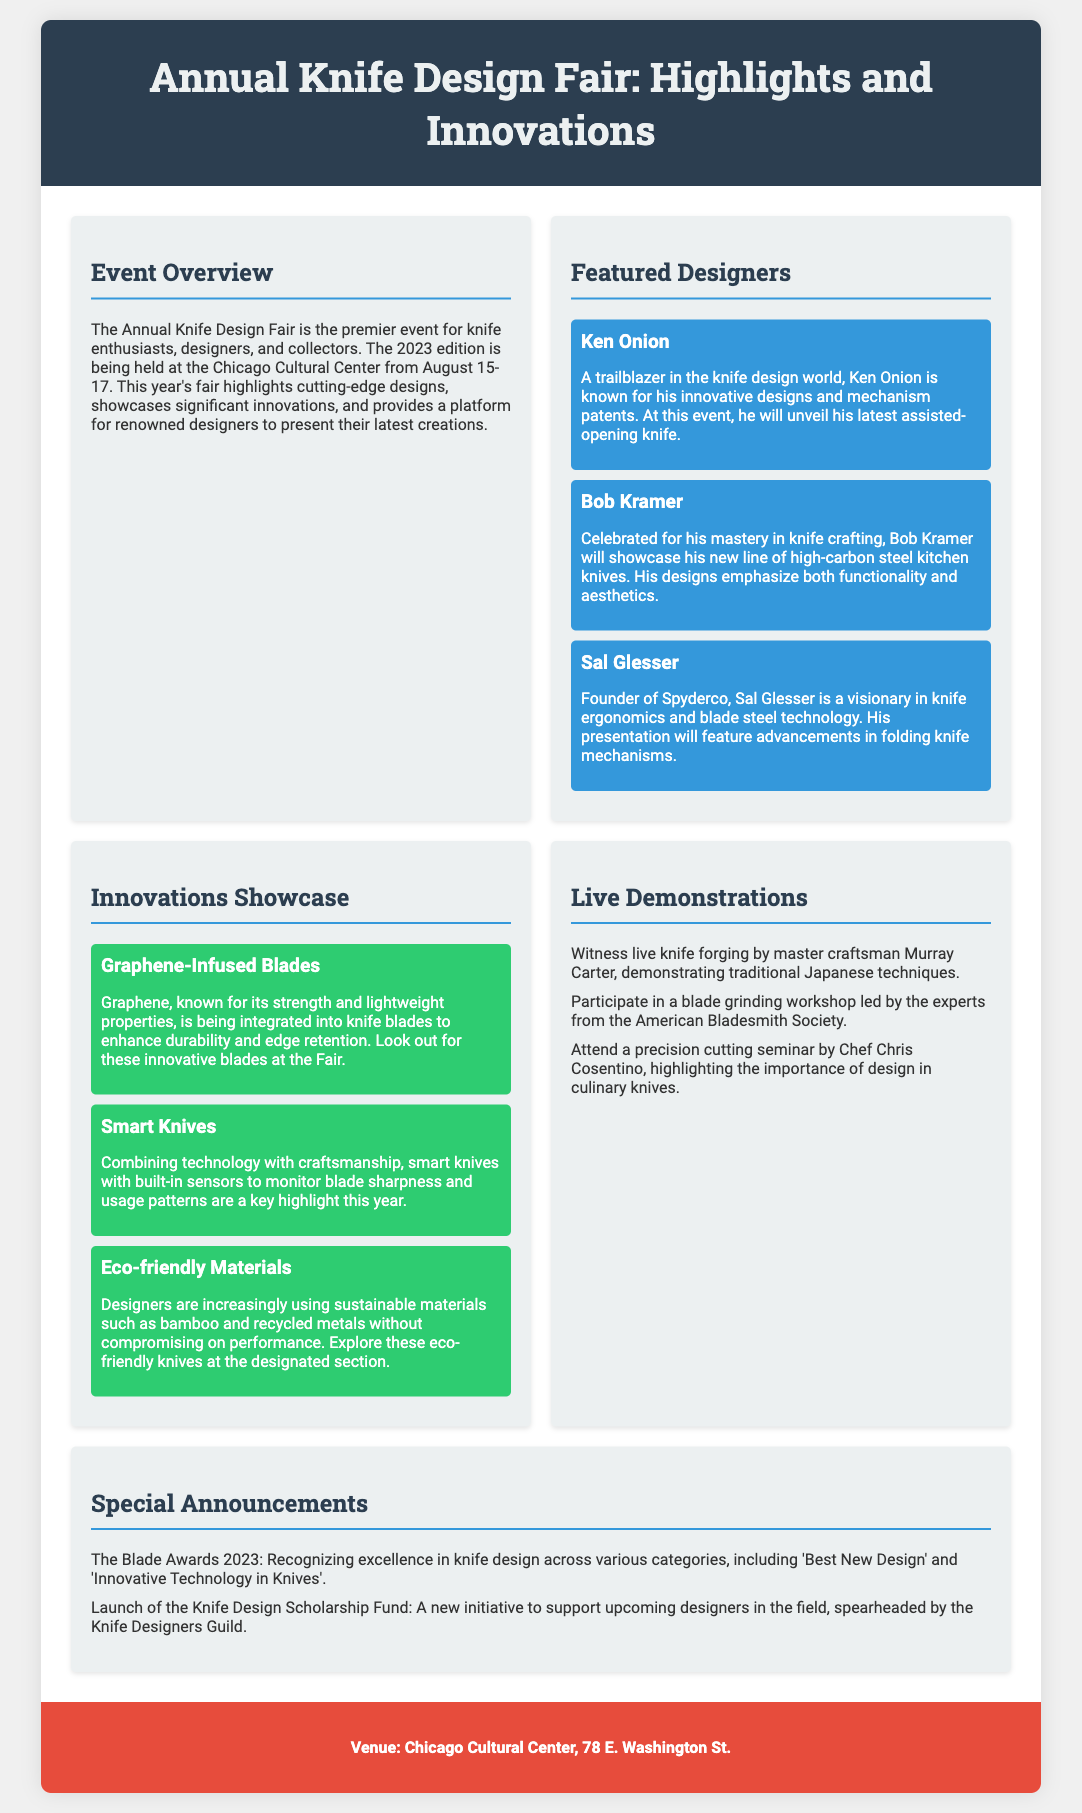What are the dates of the event? The document specifies that the event is being held from August 15-17.
Answer: August 15-17 Who is known for his innovative designs and mechanism patents? Ken Onion is mentioned as a trailblazer in knife design known for his innovations.
Answer: Ken Onion What material is being integrated into knife blades for durability? The document states that graphene is being integrated into knife blades.
Answer: Graphene Who will showcase his new line of high-carbon steel kitchen knives? Bob Kramer is highlighted for showcasing his new knife line.
Answer: Bob Kramer What is the venue of the Annual Knife Design Fair? The venue is explicitly stated as the Chicago Cultural Center.
Answer: Chicago Cultural Center What type of knives will feature built-in sensors? The document mentions that smart knives will have built-in sensors.
Answer: Smart knives Which award is recognizing excellence in knife design? The Blade Awards 2023 is mentioned for recognizing excellence.
Answer: Blade Awards 2023 What is the purpose of the Knife Design Scholarship Fund? The fund is intended to support upcoming designers in the field.
Answer: Support upcoming designers 